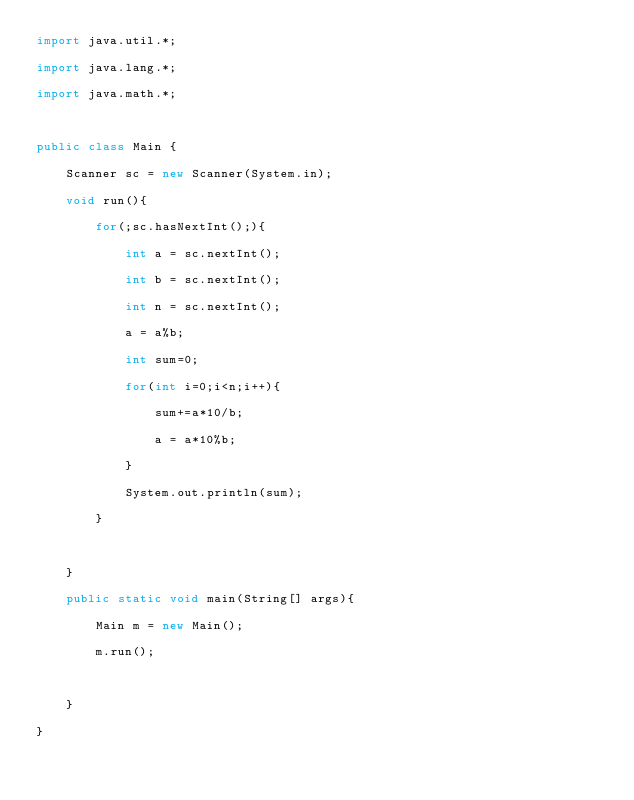Convert code to text. <code><loc_0><loc_0><loc_500><loc_500><_Java_>import java.util.*;

import java.lang.*;

import java.math.*;



public class Main {

	Scanner sc = new Scanner(System.in);

	void run(){

		for(;sc.hasNextInt();){

			int a = sc.nextInt();

			int b = sc.nextInt();

			int n = sc.nextInt();

			a = a%b;

			int sum=0;

			for(int i=0;i<n;i++){

				sum+=a*10/b;

				a = a*10%b;

			}

			System.out.println(sum);

		}

		

	}

	public static void main(String[] args){

		Main m = new Main();

		m.run();

		

	}

}</code> 